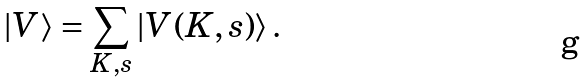Convert formula to latex. <formula><loc_0><loc_0><loc_500><loc_500>| V \rangle = \sum _ { K , s } | V ( K , s ) \rangle \, .</formula> 